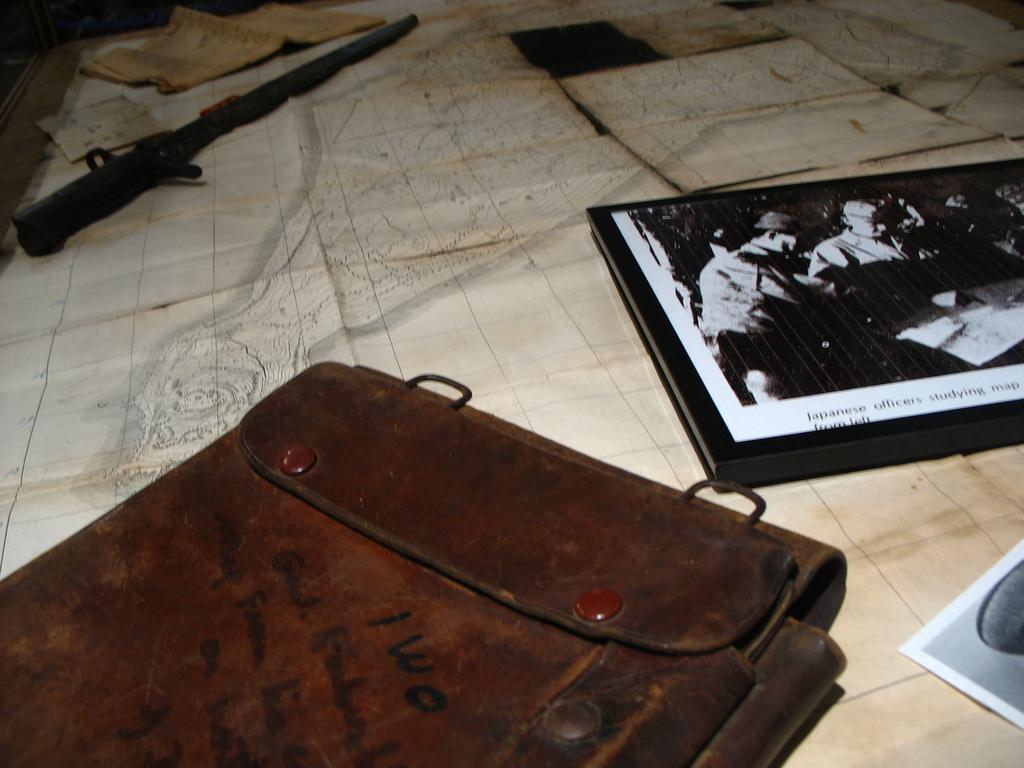In one or two sentences, can you explain what this image depicts? In this picture we can see a bag, book, gun, papers, photos and these all are placed on a table. 